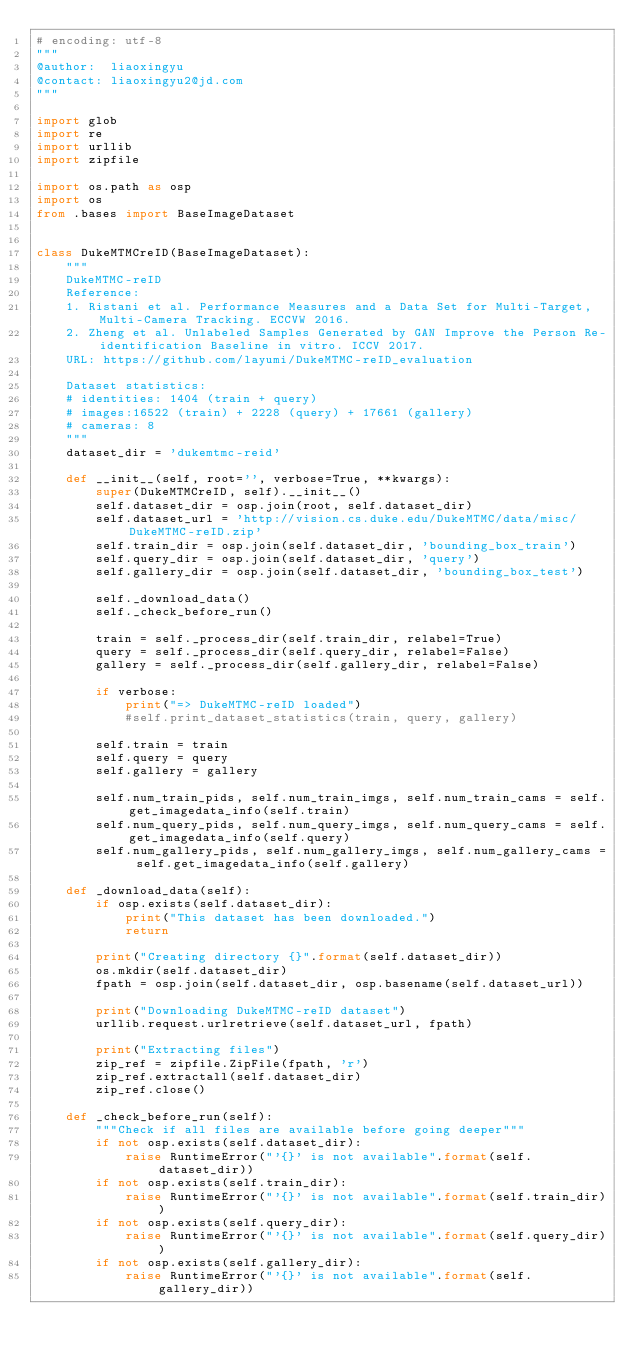Convert code to text. <code><loc_0><loc_0><loc_500><loc_500><_Python_># encoding: utf-8
"""
@author:  liaoxingyu
@contact: liaoxingyu2@jd.com
"""

import glob
import re
import urllib
import zipfile

import os.path as osp
import os
from .bases import BaseImageDataset


class DukeMTMCreID(BaseImageDataset):
    """
    DukeMTMC-reID
    Reference:
    1. Ristani et al. Performance Measures and a Data Set for Multi-Target, Multi-Camera Tracking. ECCVW 2016.
    2. Zheng et al. Unlabeled Samples Generated by GAN Improve the Person Re-identification Baseline in vitro. ICCV 2017.
    URL: https://github.com/layumi/DukeMTMC-reID_evaluation

    Dataset statistics:
    # identities: 1404 (train + query)
    # images:16522 (train) + 2228 (query) + 17661 (gallery)
    # cameras: 8
    """
    dataset_dir = 'dukemtmc-reid'

    def __init__(self, root='', verbose=True, **kwargs):
        super(DukeMTMCreID, self).__init__()
        self.dataset_dir = osp.join(root, self.dataset_dir)
        self.dataset_url = 'http://vision.cs.duke.edu/DukeMTMC/data/misc/DukeMTMC-reID.zip'
        self.train_dir = osp.join(self.dataset_dir, 'bounding_box_train')
        self.query_dir = osp.join(self.dataset_dir, 'query')
        self.gallery_dir = osp.join(self.dataset_dir, 'bounding_box_test')

        self._download_data()
        self._check_before_run()

        train = self._process_dir(self.train_dir, relabel=True)
        query = self._process_dir(self.query_dir, relabel=False)
        gallery = self._process_dir(self.gallery_dir, relabel=False)

        if verbose:
            print("=> DukeMTMC-reID loaded")
            #self.print_dataset_statistics(train, query, gallery)

        self.train = train
        self.query = query
        self.gallery = gallery

        self.num_train_pids, self.num_train_imgs, self.num_train_cams = self.get_imagedata_info(self.train)
        self.num_query_pids, self.num_query_imgs, self.num_query_cams = self.get_imagedata_info(self.query)
        self.num_gallery_pids, self.num_gallery_imgs, self.num_gallery_cams = self.get_imagedata_info(self.gallery)

    def _download_data(self):
        if osp.exists(self.dataset_dir):
            print("This dataset has been downloaded.")
            return

        print("Creating directory {}".format(self.dataset_dir))
        os.mkdir(self.dataset_dir)
        fpath = osp.join(self.dataset_dir, osp.basename(self.dataset_url))

        print("Downloading DukeMTMC-reID dataset")
        urllib.request.urlretrieve(self.dataset_url, fpath)

        print("Extracting files")
        zip_ref = zipfile.ZipFile(fpath, 'r')
        zip_ref.extractall(self.dataset_dir)
        zip_ref.close()

    def _check_before_run(self):
        """Check if all files are available before going deeper"""
        if not osp.exists(self.dataset_dir):
            raise RuntimeError("'{}' is not available".format(self.dataset_dir))
        if not osp.exists(self.train_dir):
            raise RuntimeError("'{}' is not available".format(self.train_dir))
        if not osp.exists(self.query_dir):
            raise RuntimeError("'{}' is not available".format(self.query_dir))
        if not osp.exists(self.gallery_dir):
            raise RuntimeError("'{}' is not available".format(self.gallery_dir))
</code> 